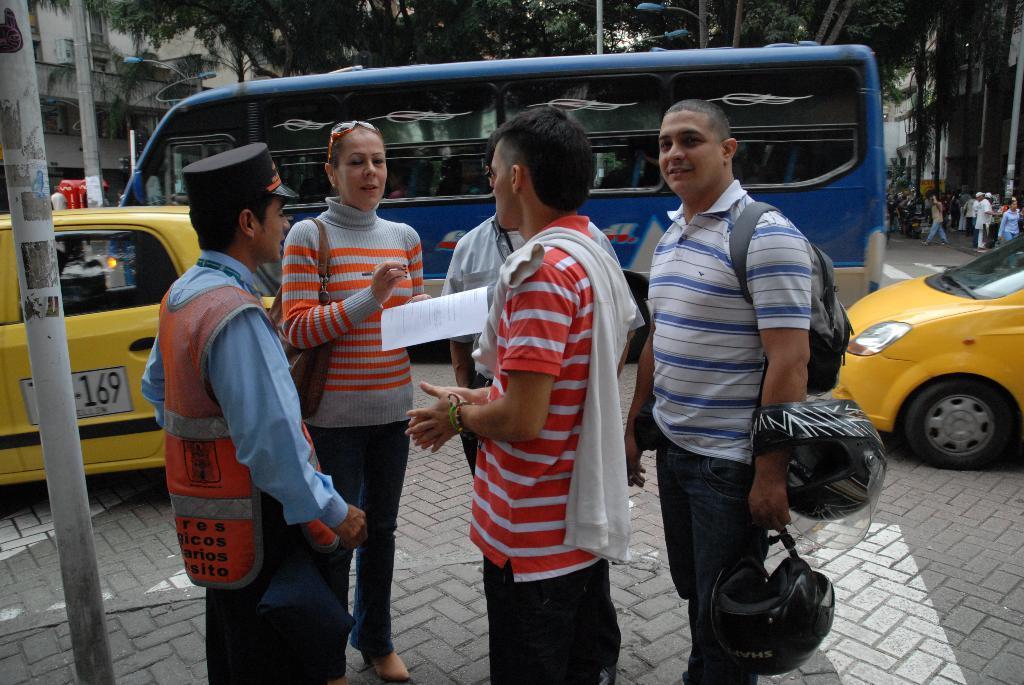Can you describe this image briefly? people are standing. A person is holding helmets and wearing a bag. A person is holding papers and pen. There are poles, vehicles, people and buildings at the back. 